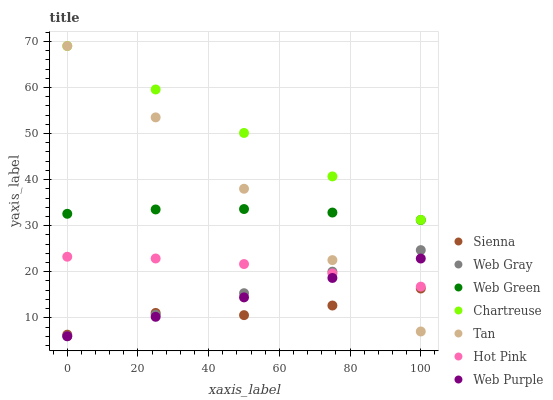Does Sienna have the minimum area under the curve?
Answer yes or no. Yes. Does Chartreuse have the maximum area under the curve?
Answer yes or no. Yes. Does Hot Pink have the minimum area under the curve?
Answer yes or no. No. Does Hot Pink have the maximum area under the curve?
Answer yes or no. No. Is Web Purple the smoothest?
Answer yes or no. Yes. Is Sienna the roughest?
Answer yes or no. Yes. Is Hot Pink the smoothest?
Answer yes or no. No. Is Hot Pink the roughest?
Answer yes or no. No. Does Web Gray have the lowest value?
Answer yes or no. Yes. Does Hot Pink have the lowest value?
Answer yes or no. No. Does Tan have the highest value?
Answer yes or no. Yes. Does Hot Pink have the highest value?
Answer yes or no. No. Is Hot Pink less than Chartreuse?
Answer yes or no. Yes. Is Web Green greater than Sienna?
Answer yes or no. Yes. Does Tan intersect Web Gray?
Answer yes or no. Yes. Is Tan less than Web Gray?
Answer yes or no. No. Is Tan greater than Web Gray?
Answer yes or no. No. Does Hot Pink intersect Chartreuse?
Answer yes or no. No. 